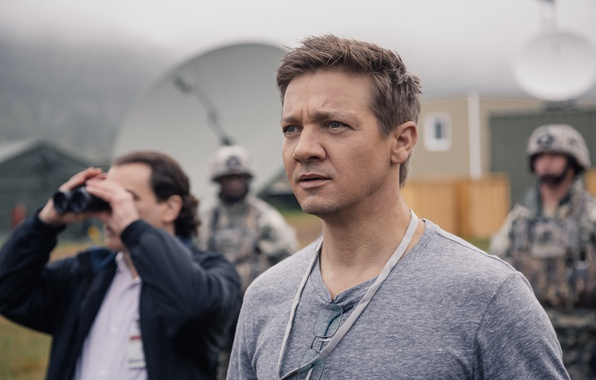What are the key elements in the image that suggest its setting? The key elements suggesting the setting of the image include the presence of individuals in military uniforms, satellite dishes, and other technical equipment. The lanyard worn by the central figure and the binoculars held by another person also hint at a formal, operational context, likely a military base or a high-security installation. Why might the central figure be looking so focused and serious? The central figure's focused and serious expression suggests he might be observing or considering an important matter out of the frame. Given the setting, it's plausible that he is involved in a significant operation or event requiring concentration and attentiveness, possibly related to military or security concerns. 